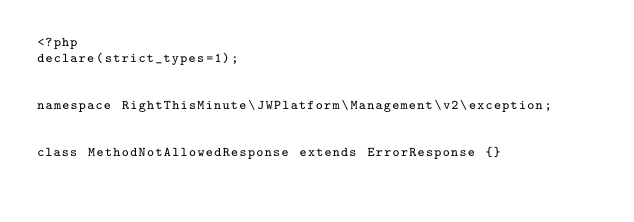Convert code to text. <code><loc_0><loc_0><loc_500><loc_500><_PHP_><?php
declare(strict_types=1);


namespace RightThisMinute\JWPlatform\Management\v2\exception;


class MethodNotAllowedResponse extends ErrorResponse {}
</code> 